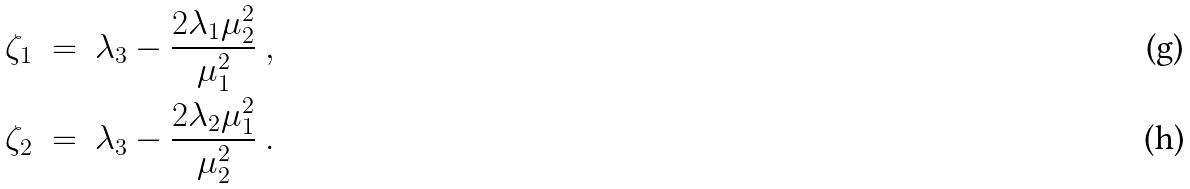Convert formula to latex. <formula><loc_0><loc_0><loc_500><loc_500>\zeta _ { 1 } \ & = \ \lambda _ { 3 } - \frac { 2 \lambda _ { 1 } \mu _ { 2 } ^ { 2 } } { \mu _ { 1 } ^ { 2 } } \ , \\ \zeta _ { 2 } \ & = \ \lambda _ { 3 } - \frac { 2 \lambda _ { 2 } \mu _ { 1 } ^ { 2 } } { \mu _ { 2 } ^ { 2 } } \ .</formula> 